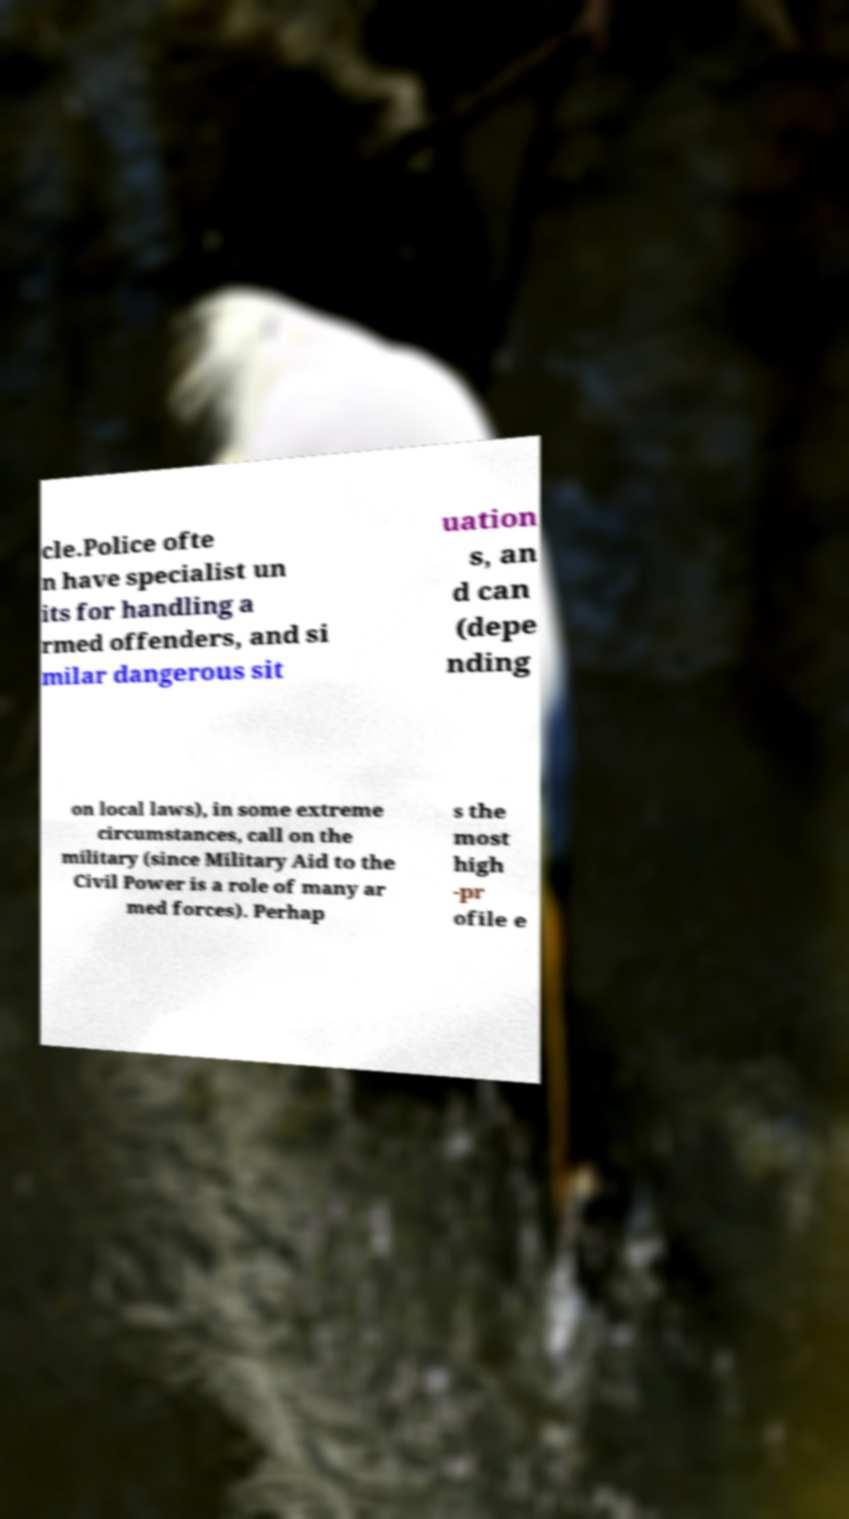What messages or text are displayed in this image? I need them in a readable, typed format. cle.Police ofte n have specialist un its for handling a rmed offenders, and si milar dangerous sit uation s, an d can (depe nding on local laws), in some extreme circumstances, call on the military (since Military Aid to the Civil Power is a role of many ar med forces). Perhap s the most high -pr ofile e 